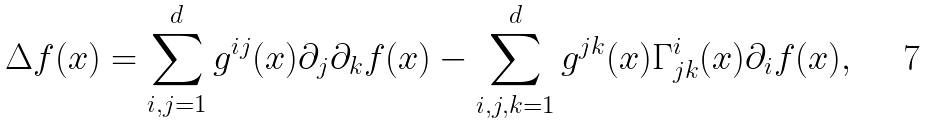<formula> <loc_0><loc_0><loc_500><loc_500>\Delta f ( x ) = \sum _ { i , j = 1 } ^ { d } g ^ { i j } ( x ) \partial _ { j } \partial _ { k } f ( x ) - \sum _ { i , j , k = 1 } ^ { d } g ^ { j k } ( x ) \Gamma ^ { i } _ { j k } ( x ) \partial _ { i } f ( x ) ,</formula> 